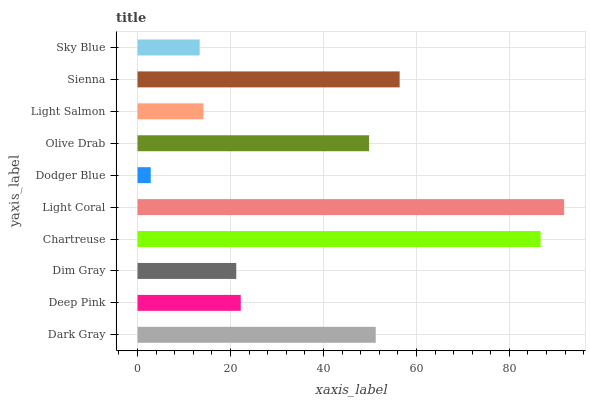Is Dodger Blue the minimum?
Answer yes or no. Yes. Is Light Coral the maximum?
Answer yes or no. Yes. Is Deep Pink the minimum?
Answer yes or no. No. Is Deep Pink the maximum?
Answer yes or no. No. Is Dark Gray greater than Deep Pink?
Answer yes or no. Yes. Is Deep Pink less than Dark Gray?
Answer yes or no. Yes. Is Deep Pink greater than Dark Gray?
Answer yes or no. No. Is Dark Gray less than Deep Pink?
Answer yes or no. No. Is Olive Drab the high median?
Answer yes or no. Yes. Is Deep Pink the low median?
Answer yes or no. Yes. Is Sienna the high median?
Answer yes or no. No. Is Dim Gray the low median?
Answer yes or no. No. 